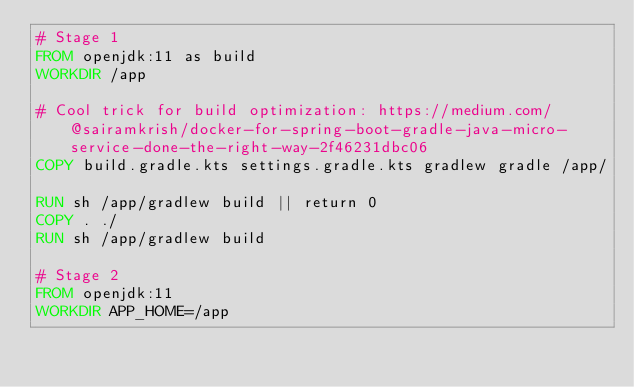<code> <loc_0><loc_0><loc_500><loc_500><_Dockerfile_># Stage 1
FROM openjdk:11 as build
WORKDIR /app

# Cool trick for build optimization: https://medium.com/@sairamkrish/docker-for-spring-boot-gradle-java-micro-service-done-the-right-way-2f46231dbc06
COPY build.gradle.kts settings.gradle.kts gradlew gradle /app/

RUN sh /app/gradlew build || return 0
COPY . ./
RUN sh /app/gradlew build

# Stage 2
FROM openjdk:11
WORKDIR APP_HOME=/app</code> 